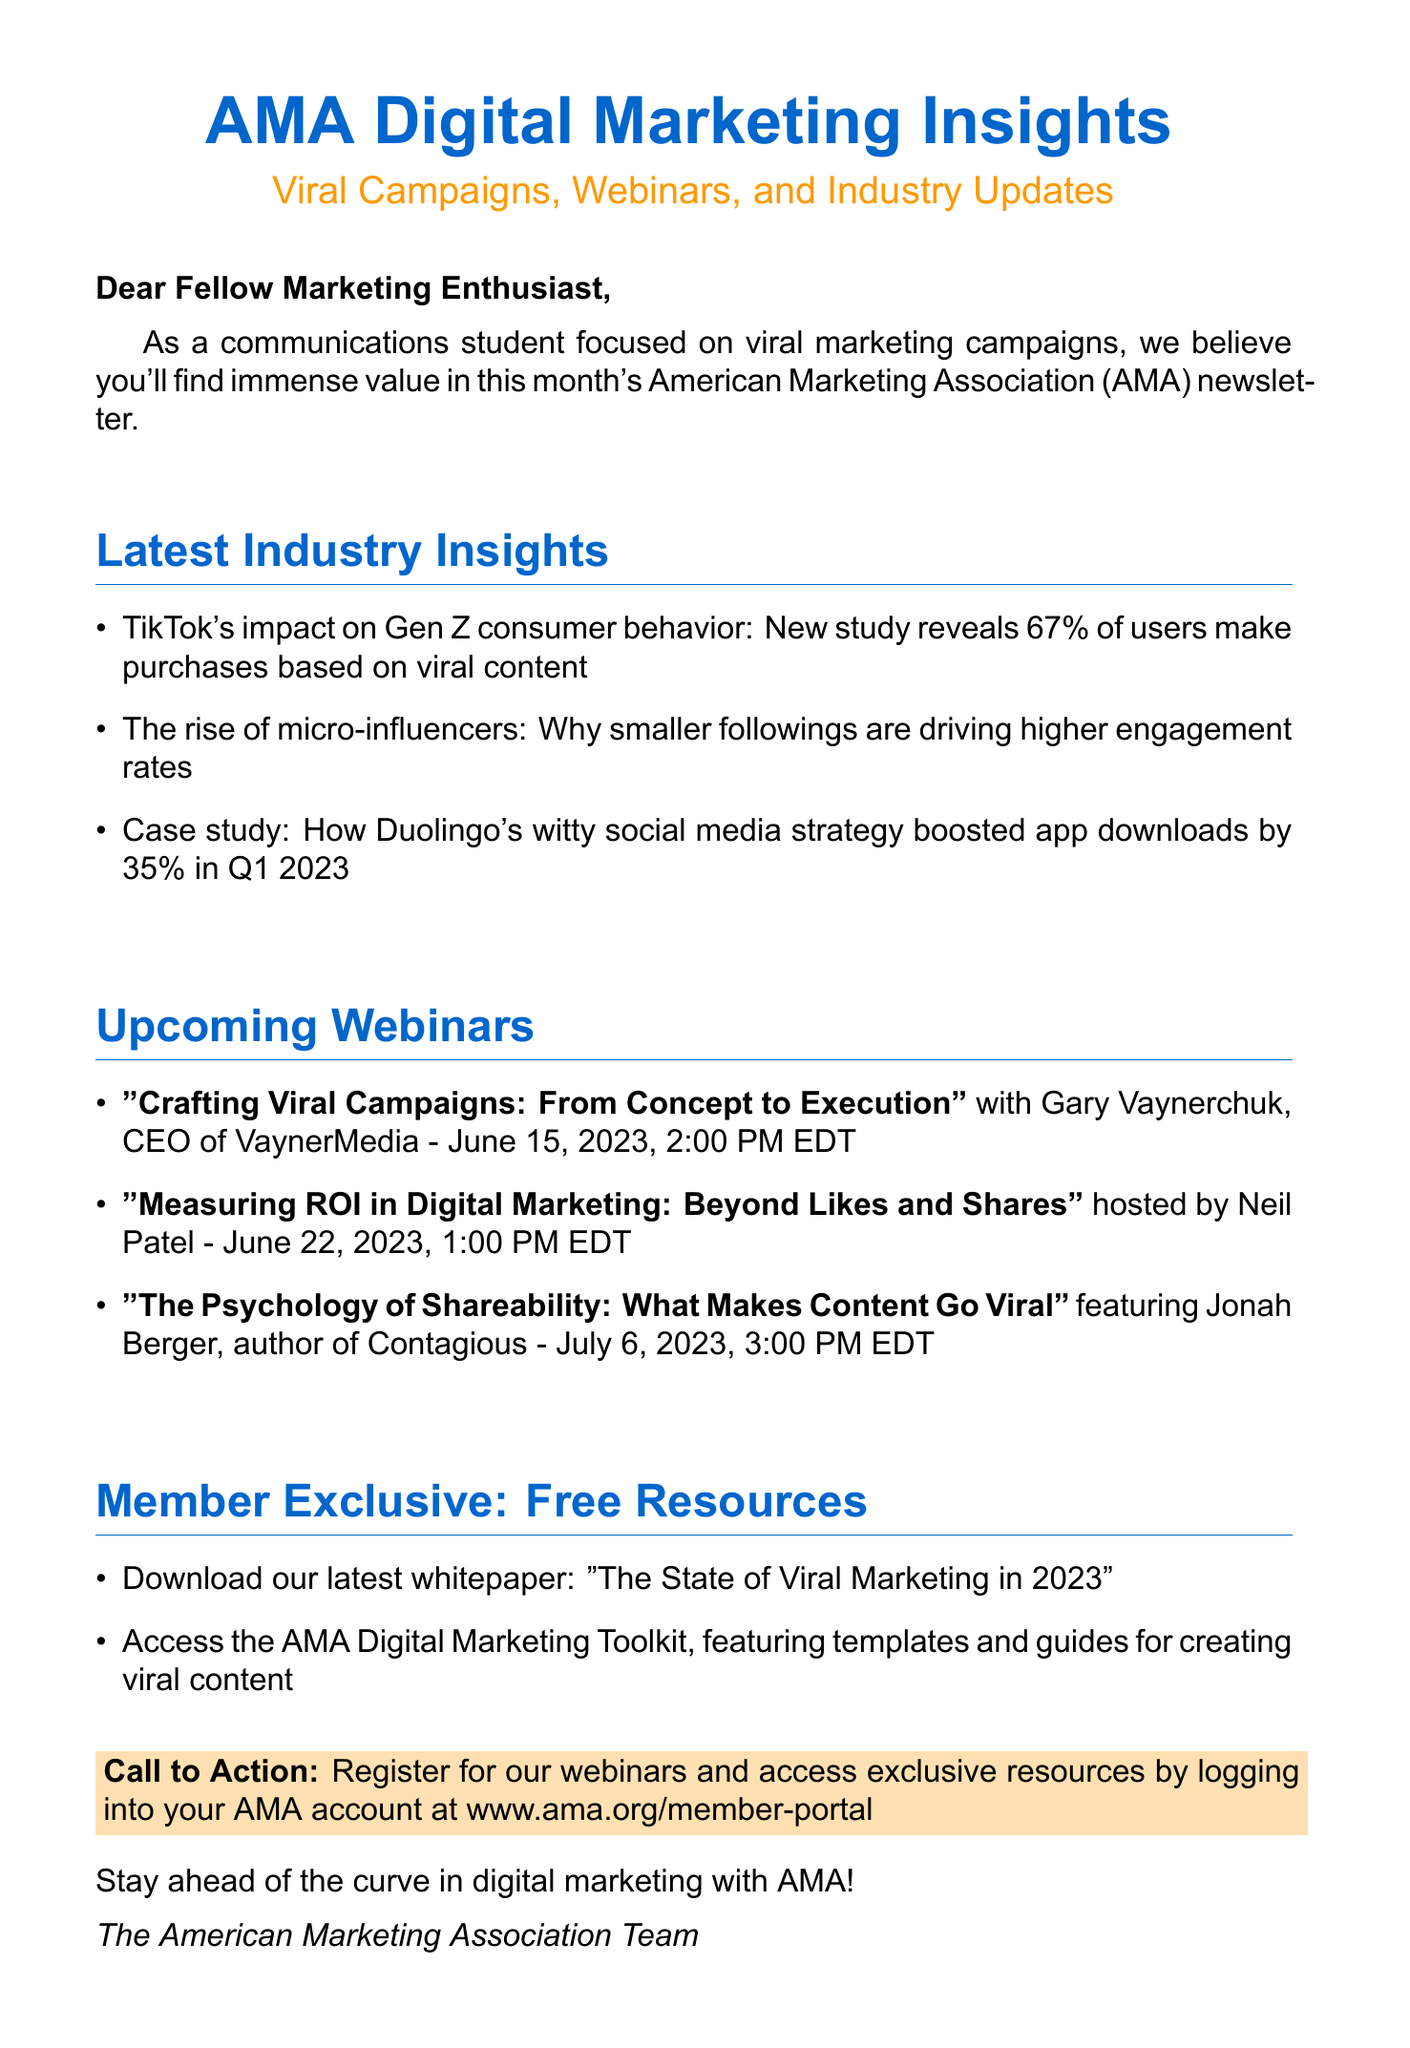What is the subject of the email? The subject line provides the key topic of the email, which is a summary of its contents.
Answer: AMA Digital Marketing Insights: Viral Campaigns, Webinars, and Industry Updates Who is the speaker for the webinar on June 15, 2023? This question focuses on the specific details of the upcoming webinars outlined in the document.
Answer: Gary Vaynerchuk What percentage of Gen Z TikTok users make purchases based on viral content? This question requires extracting a statistic from the industry insights section of the email.
Answer: 67% What is the title of the free whitepaper available to members? Members are offered specific resources, including a whitepaper that is mentioned in the document.
Answer: The State of Viral Marketing in 2023 How many webinars are listed in the email? This requires summing the total webinars provided in the list, reflecting the structure of the content.
Answer: 3 What date is the webinar about measuring ROI in digital marketing? This question looks for a specific date mentioned in the webinars section.
Answer: June 22, 2023 What is the main purpose of the email? Understanding the intent behind the communication helps grasp its overall significance.
Answer: To provide industry insights and promote webinars Who is the author of the book 'Contagious'? This focuses on identifying an individual mentioned in the context of an upcoming webinar.
Answer: Jonah Berger 